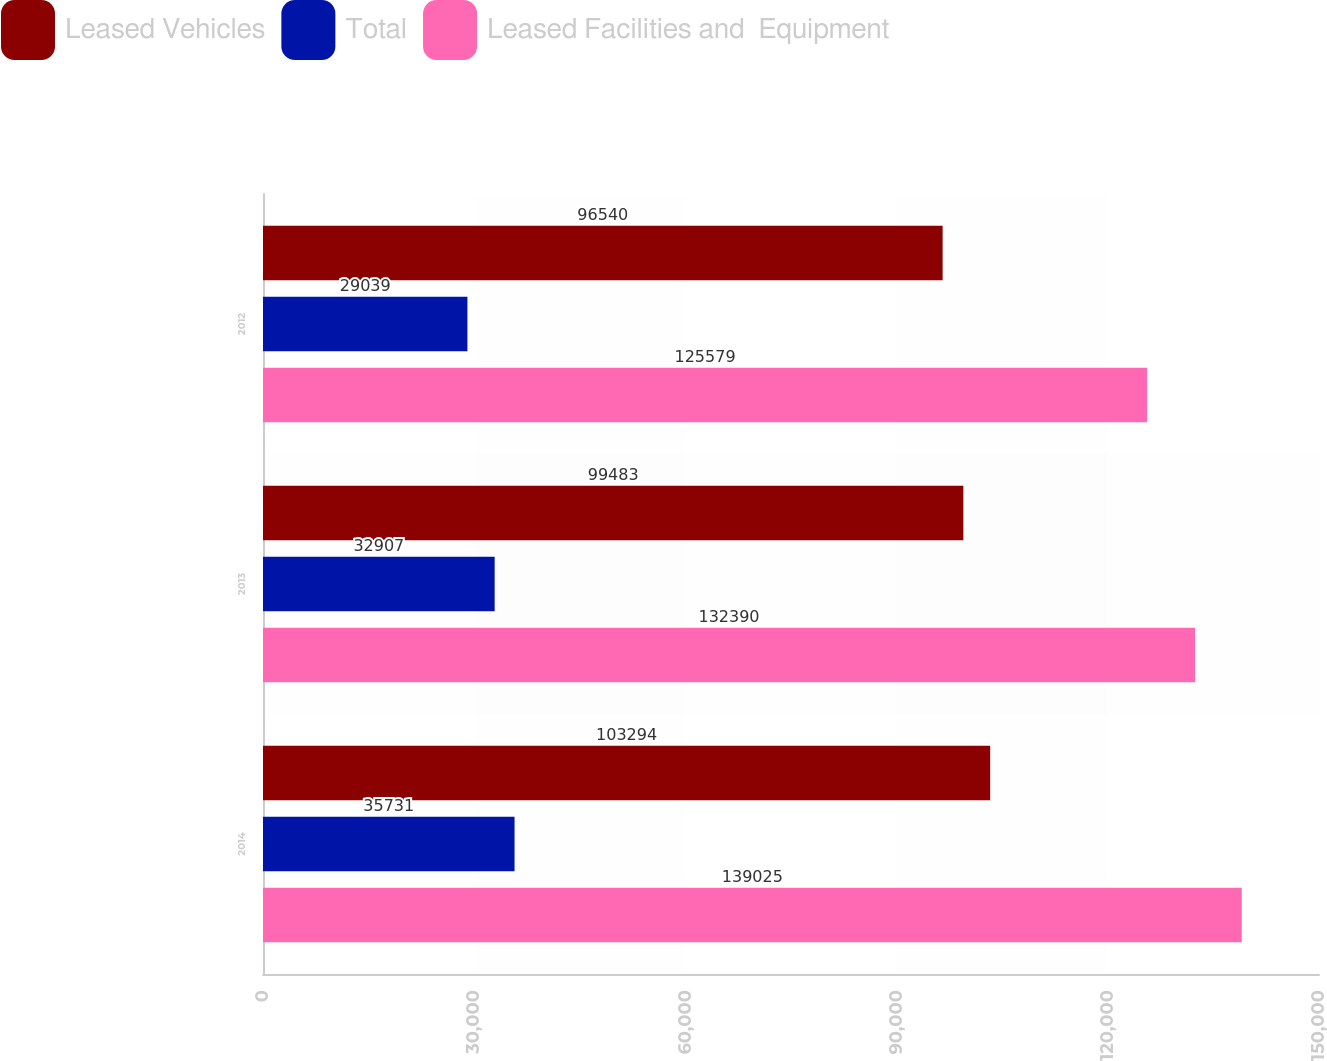Convert chart to OTSL. <chart><loc_0><loc_0><loc_500><loc_500><stacked_bar_chart><ecel><fcel>2014<fcel>2013<fcel>2012<nl><fcel>Leased Vehicles<fcel>103294<fcel>99483<fcel>96540<nl><fcel>Total<fcel>35731<fcel>32907<fcel>29039<nl><fcel>Leased Facilities and  Equipment<fcel>139025<fcel>132390<fcel>125579<nl></chart> 